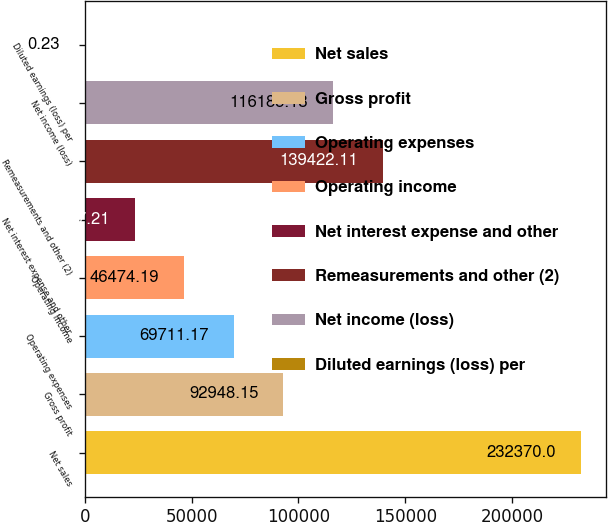Convert chart. <chart><loc_0><loc_0><loc_500><loc_500><bar_chart><fcel>Net sales<fcel>Gross profit<fcel>Operating expenses<fcel>Operating income<fcel>Net interest expense and other<fcel>Remeasurements and other (2)<fcel>Net income (loss)<fcel>Diluted earnings (loss) per<nl><fcel>232370<fcel>92948.1<fcel>69711.2<fcel>46474.2<fcel>23237.2<fcel>139422<fcel>116185<fcel>0.23<nl></chart> 